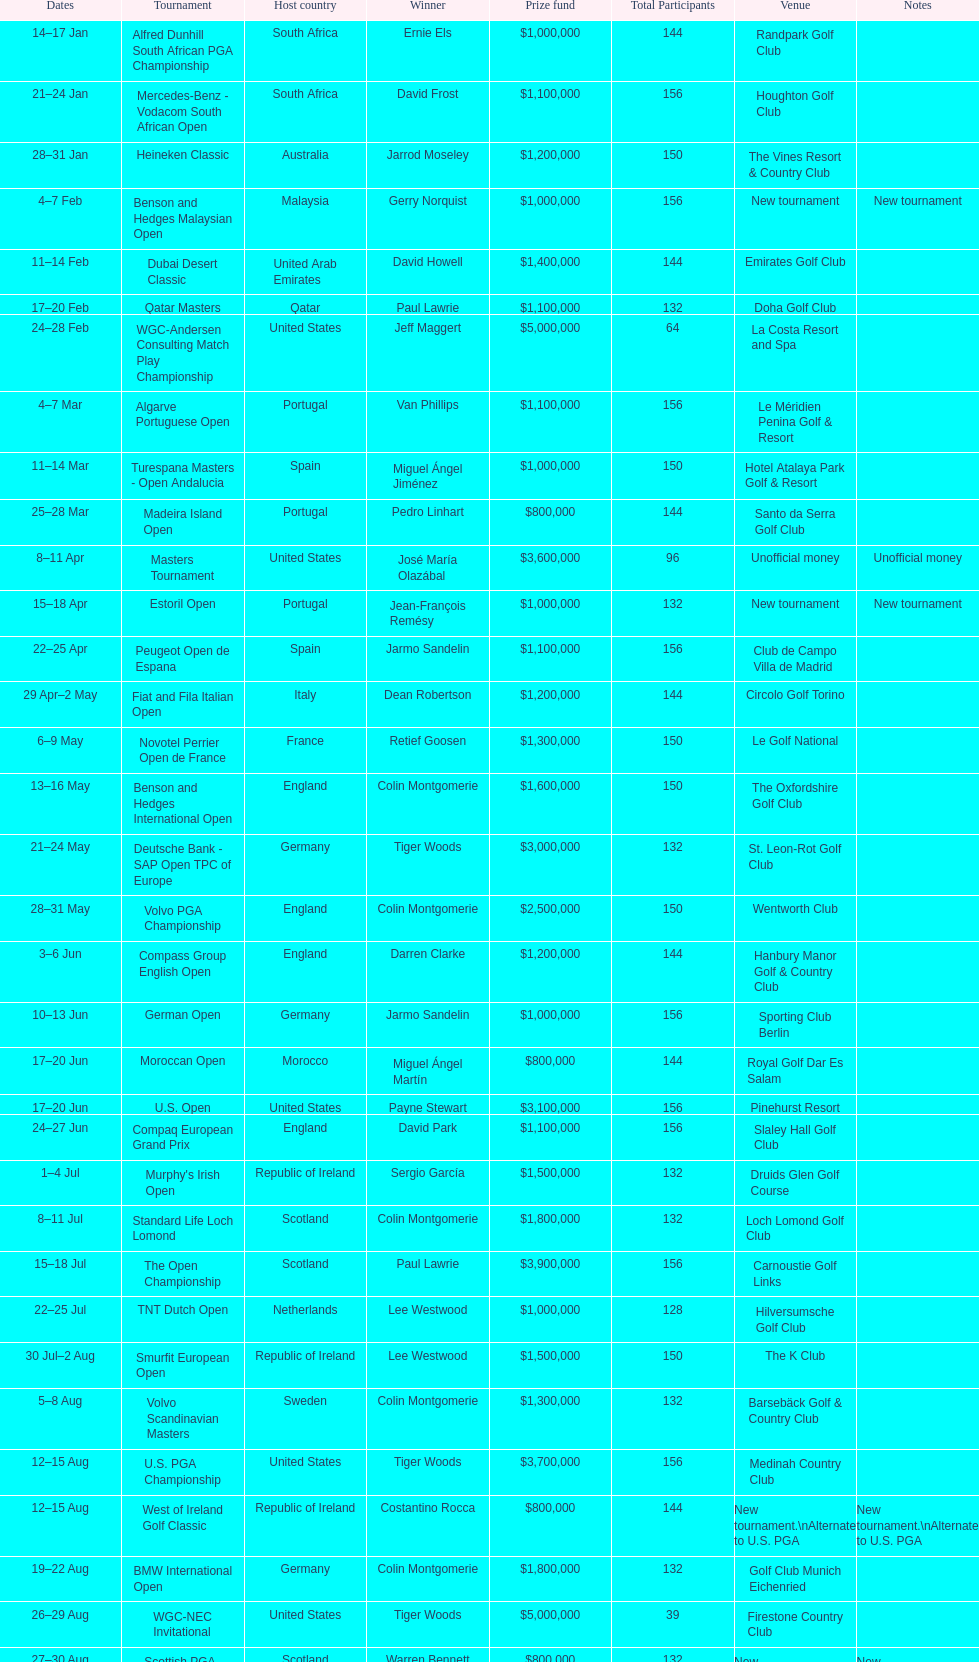How many tournaments began before aug 15th 31. 